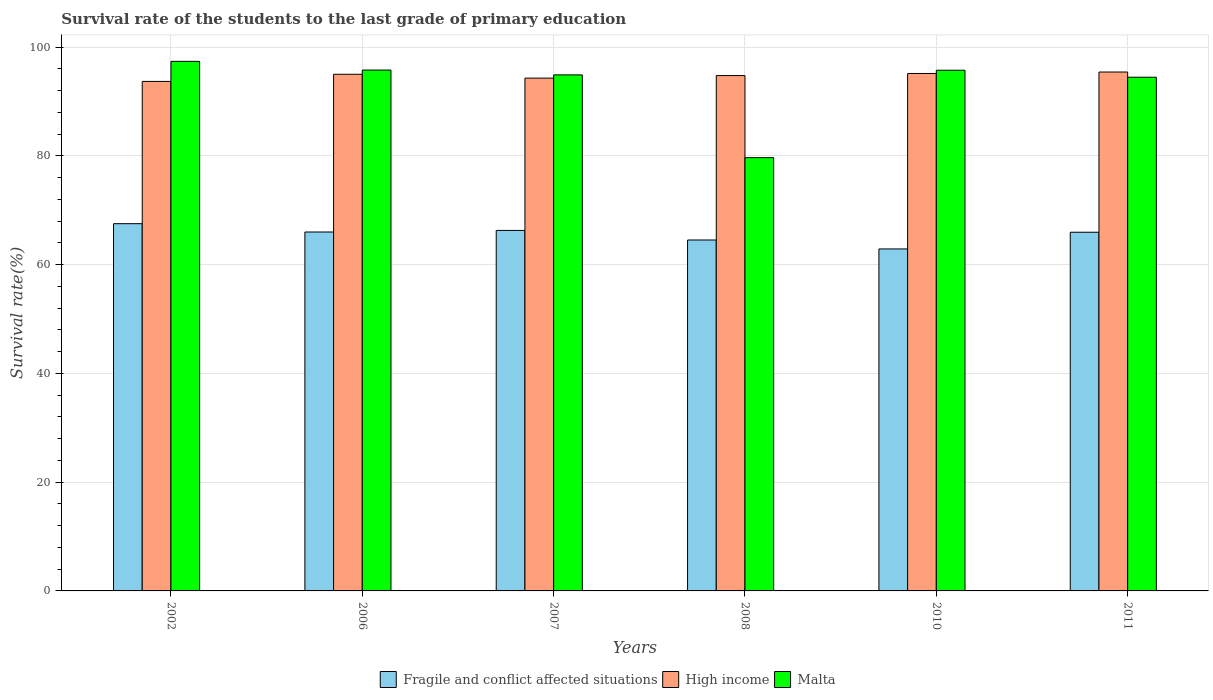How many groups of bars are there?
Offer a terse response. 6. How many bars are there on the 5th tick from the left?
Your response must be concise. 3. What is the label of the 3rd group of bars from the left?
Your answer should be very brief. 2007. What is the survival rate of the students in High income in 2010?
Provide a succinct answer. 95.15. Across all years, what is the maximum survival rate of the students in Fragile and conflict affected situations?
Keep it short and to the point. 67.53. Across all years, what is the minimum survival rate of the students in High income?
Make the answer very short. 93.69. In which year was the survival rate of the students in Fragile and conflict affected situations maximum?
Offer a very short reply. 2002. In which year was the survival rate of the students in Malta minimum?
Your answer should be compact. 2008. What is the total survival rate of the students in High income in the graph?
Offer a very short reply. 568.33. What is the difference between the survival rate of the students in High income in 2002 and that in 2006?
Keep it short and to the point. -1.31. What is the difference between the survival rate of the students in Fragile and conflict affected situations in 2008 and the survival rate of the students in High income in 2002?
Your answer should be very brief. -29.16. What is the average survival rate of the students in Fragile and conflict affected situations per year?
Ensure brevity in your answer.  65.53. In the year 2006, what is the difference between the survival rate of the students in Malta and survival rate of the students in Fragile and conflict affected situations?
Your response must be concise. 29.78. In how many years, is the survival rate of the students in Malta greater than 56 %?
Your answer should be very brief. 6. What is the ratio of the survival rate of the students in High income in 2002 to that in 2010?
Give a very brief answer. 0.98. Is the survival rate of the students in Malta in 2002 less than that in 2008?
Ensure brevity in your answer.  No. Is the difference between the survival rate of the students in Malta in 2002 and 2007 greater than the difference between the survival rate of the students in Fragile and conflict affected situations in 2002 and 2007?
Provide a short and direct response. Yes. What is the difference between the highest and the second highest survival rate of the students in High income?
Your answer should be compact. 0.27. What is the difference between the highest and the lowest survival rate of the students in High income?
Give a very brief answer. 1.73. What does the 1st bar from the left in 2008 represents?
Give a very brief answer. Fragile and conflict affected situations. What does the 2nd bar from the right in 2011 represents?
Keep it short and to the point. High income. How many bars are there?
Offer a terse response. 18. How many years are there in the graph?
Your answer should be compact. 6. Where does the legend appear in the graph?
Make the answer very short. Bottom center. How are the legend labels stacked?
Offer a terse response. Horizontal. What is the title of the graph?
Make the answer very short. Survival rate of the students to the last grade of primary education. Does "Papua New Guinea" appear as one of the legend labels in the graph?
Give a very brief answer. No. What is the label or title of the Y-axis?
Provide a succinct answer. Survival rate(%). What is the Survival rate(%) in Fragile and conflict affected situations in 2002?
Ensure brevity in your answer.  67.53. What is the Survival rate(%) in High income in 2002?
Offer a very short reply. 93.69. What is the Survival rate(%) of Malta in 2002?
Provide a short and direct response. 97.38. What is the Survival rate(%) of Fragile and conflict affected situations in 2006?
Your answer should be compact. 66. What is the Survival rate(%) in High income in 2006?
Provide a short and direct response. 95. What is the Survival rate(%) in Malta in 2006?
Provide a succinct answer. 95.78. What is the Survival rate(%) in Fragile and conflict affected situations in 2007?
Keep it short and to the point. 66.29. What is the Survival rate(%) of High income in 2007?
Keep it short and to the point. 94.3. What is the Survival rate(%) in Malta in 2007?
Give a very brief answer. 94.89. What is the Survival rate(%) in Fragile and conflict affected situations in 2008?
Your answer should be very brief. 64.53. What is the Survival rate(%) of High income in 2008?
Keep it short and to the point. 94.77. What is the Survival rate(%) in Malta in 2008?
Offer a terse response. 79.67. What is the Survival rate(%) in Fragile and conflict affected situations in 2010?
Your answer should be very brief. 62.88. What is the Survival rate(%) of High income in 2010?
Your answer should be compact. 95.15. What is the Survival rate(%) in Malta in 2010?
Give a very brief answer. 95.75. What is the Survival rate(%) in Fragile and conflict affected situations in 2011?
Make the answer very short. 65.96. What is the Survival rate(%) of High income in 2011?
Your response must be concise. 95.42. What is the Survival rate(%) in Malta in 2011?
Give a very brief answer. 94.46. Across all years, what is the maximum Survival rate(%) of Fragile and conflict affected situations?
Offer a terse response. 67.53. Across all years, what is the maximum Survival rate(%) in High income?
Your answer should be very brief. 95.42. Across all years, what is the maximum Survival rate(%) in Malta?
Give a very brief answer. 97.38. Across all years, what is the minimum Survival rate(%) in Fragile and conflict affected situations?
Offer a terse response. 62.88. Across all years, what is the minimum Survival rate(%) in High income?
Your answer should be very brief. 93.69. Across all years, what is the minimum Survival rate(%) of Malta?
Your answer should be very brief. 79.67. What is the total Survival rate(%) of Fragile and conflict affected situations in the graph?
Offer a very short reply. 393.19. What is the total Survival rate(%) in High income in the graph?
Offer a terse response. 568.33. What is the total Survival rate(%) in Malta in the graph?
Provide a succinct answer. 557.94. What is the difference between the Survival rate(%) in Fragile and conflict affected situations in 2002 and that in 2006?
Provide a succinct answer. 1.53. What is the difference between the Survival rate(%) in High income in 2002 and that in 2006?
Give a very brief answer. -1.31. What is the difference between the Survival rate(%) of Malta in 2002 and that in 2006?
Provide a succinct answer. 1.6. What is the difference between the Survival rate(%) of Fragile and conflict affected situations in 2002 and that in 2007?
Make the answer very short. 1.24. What is the difference between the Survival rate(%) of High income in 2002 and that in 2007?
Make the answer very short. -0.6. What is the difference between the Survival rate(%) in Malta in 2002 and that in 2007?
Give a very brief answer. 2.49. What is the difference between the Survival rate(%) of Fragile and conflict affected situations in 2002 and that in 2008?
Your response must be concise. 3. What is the difference between the Survival rate(%) in High income in 2002 and that in 2008?
Provide a short and direct response. -1.07. What is the difference between the Survival rate(%) in Malta in 2002 and that in 2008?
Give a very brief answer. 17.71. What is the difference between the Survival rate(%) in Fragile and conflict affected situations in 2002 and that in 2010?
Give a very brief answer. 4.65. What is the difference between the Survival rate(%) of High income in 2002 and that in 2010?
Keep it short and to the point. -1.46. What is the difference between the Survival rate(%) of Malta in 2002 and that in 2010?
Keep it short and to the point. 1.63. What is the difference between the Survival rate(%) in Fragile and conflict affected situations in 2002 and that in 2011?
Provide a short and direct response. 1.58. What is the difference between the Survival rate(%) of High income in 2002 and that in 2011?
Keep it short and to the point. -1.73. What is the difference between the Survival rate(%) of Malta in 2002 and that in 2011?
Keep it short and to the point. 2.92. What is the difference between the Survival rate(%) of Fragile and conflict affected situations in 2006 and that in 2007?
Your response must be concise. -0.29. What is the difference between the Survival rate(%) of High income in 2006 and that in 2007?
Give a very brief answer. 0.71. What is the difference between the Survival rate(%) in Malta in 2006 and that in 2007?
Your response must be concise. 0.89. What is the difference between the Survival rate(%) in Fragile and conflict affected situations in 2006 and that in 2008?
Provide a succinct answer. 1.47. What is the difference between the Survival rate(%) of High income in 2006 and that in 2008?
Your answer should be compact. 0.24. What is the difference between the Survival rate(%) in Malta in 2006 and that in 2008?
Your answer should be very brief. 16.11. What is the difference between the Survival rate(%) in Fragile and conflict affected situations in 2006 and that in 2010?
Your answer should be compact. 3.11. What is the difference between the Survival rate(%) of High income in 2006 and that in 2010?
Your answer should be compact. -0.15. What is the difference between the Survival rate(%) in Malta in 2006 and that in 2010?
Your response must be concise. 0.03. What is the difference between the Survival rate(%) in Fragile and conflict affected situations in 2006 and that in 2011?
Ensure brevity in your answer.  0.04. What is the difference between the Survival rate(%) in High income in 2006 and that in 2011?
Your answer should be very brief. -0.41. What is the difference between the Survival rate(%) of Malta in 2006 and that in 2011?
Give a very brief answer. 1.32. What is the difference between the Survival rate(%) of Fragile and conflict affected situations in 2007 and that in 2008?
Offer a very short reply. 1.76. What is the difference between the Survival rate(%) of High income in 2007 and that in 2008?
Make the answer very short. -0.47. What is the difference between the Survival rate(%) in Malta in 2007 and that in 2008?
Give a very brief answer. 15.22. What is the difference between the Survival rate(%) of Fragile and conflict affected situations in 2007 and that in 2010?
Offer a terse response. 3.4. What is the difference between the Survival rate(%) of High income in 2007 and that in 2010?
Your answer should be very brief. -0.85. What is the difference between the Survival rate(%) of Malta in 2007 and that in 2010?
Keep it short and to the point. -0.86. What is the difference between the Survival rate(%) in Fragile and conflict affected situations in 2007 and that in 2011?
Provide a short and direct response. 0.33. What is the difference between the Survival rate(%) in High income in 2007 and that in 2011?
Provide a short and direct response. -1.12. What is the difference between the Survival rate(%) in Malta in 2007 and that in 2011?
Give a very brief answer. 0.43. What is the difference between the Survival rate(%) of Fragile and conflict affected situations in 2008 and that in 2010?
Offer a terse response. 1.65. What is the difference between the Survival rate(%) of High income in 2008 and that in 2010?
Offer a very short reply. -0.39. What is the difference between the Survival rate(%) in Malta in 2008 and that in 2010?
Offer a terse response. -16.08. What is the difference between the Survival rate(%) in Fragile and conflict affected situations in 2008 and that in 2011?
Offer a very short reply. -1.43. What is the difference between the Survival rate(%) of High income in 2008 and that in 2011?
Your response must be concise. -0.65. What is the difference between the Survival rate(%) in Malta in 2008 and that in 2011?
Provide a succinct answer. -14.79. What is the difference between the Survival rate(%) in Fragile and conflict affected situations in 2010 and that in 2011?
Provide a succinct answer. -3.07. What is the difference between the Survival rate(%) in High income in 2010 and that in 2011?
Give a very brief answer. -0.27. What is the difference between the Survival rate(%) in Malta in 2010 and that in 2011?
Your answer should be very brief. 1.29. What is the difference between the Survival rate(%) in Fragile and conflict affected situations in 2002 and the Survival rate(%) in High income in 2006?
Offer a terse response. -27.47. What is the difference between the Survival rate(%) in Fragile and conflict affected situations in 2002 and the Survival rate(%) in Malta in 2006?
Offer a very short reply. -28.25. What is the difference between the Survival rate(%) of High income in 2002 and the Survival rate(%) of Malta in 2006?
Give a very brief answer. -2.09. What is the difference between the Survival rate(%) in Fragile and conflict affected situations in 2002 and the Survival rate(%) in High income in 2007?
Provide a short and direct response. -26.77. What is the difference between the Survival rate(%) of Fragile and conflict affected situations in 2002 and the Survival rate(%) of Malta in 2007?
Provide a succinct answer. -27.36. What is the difference between the Survival rate(%) of High income in 2002 and the Survival rate(%) of Malta in 2007?
Offer a terse response. -1.2. What is the difference between the Survival rate(%) of Fragile and conflict affected situations in 2002 and the Survival rate(%) of High income in 2008?
Your answer should be very brief. -27.23. What is the difference between the Survival rate(%) of Fragile and conflict affected situations in 2002 and the Survival rate(%) of Malta in 2008?
Keep it short and to the point. -12.14. What is the difference between the Survival rate(%) of High income in 2002 and the Survival rate(%) of Malta in 2008?
Offer a very short reply. 14.02. What is the difference between the Survival rate(%) of Fragile and conflict affected situations in 2002 and the Survival rate(%) of High income in 2010?
Offer a very short reply. -27.62. What is the difference between the Survival rate(%) in Fragile and conflict affected situations in 2002 and the Survival rate(%) in Malta in 2010?
Make the answer very short. -28.22. What is the difference between the Survival rate(%) of High income in 2002 and the Survival rate(%) of Malta in 2010?
Provide a succinct answer. -2.06. What is the difference between the Survival rate(%) in Fragile and conflict affected situations in 2002 and the Survival rate(%) in High income in 2011?
Offer a very short reply. -27.89. What is the difference between the Survival rate(%) in Fragile and conflict affected situations in 2002 and the Survival rate(%) in Malta in 2011?
Offer a terse response. -26.93. What is the difference between the Survival rate(%) of High income in 2002 and the Survival rate(%) of Malta in 2011?
Make the answer very short. -0.77. What is the difference between the Survival rate(%) in Fragile and conflict affected situations in 2006 and the Survival rate(%) in High income in 2007?
Offer a very short reply. -28.3. What is the difference between the Survival rate(%) in Fragile and conflict affected situations in 2006 and the Survival rate(%) in Malta in 2007?
Ensure brevity in your answer.  -28.89. What is the difference between the Survival rate(%) in High income in 2006 and the Survival rate(%) in Malta in 2007?
Offer a very short reply. 0.11. What is the difference between the Survival rate(%) of Fragile and conflict affected situations in 2006 and the Survival rate(%) of High income in 2008?
Give a very brief answer. -28.77. What is the difference between the Survival rate(%) in Fragile and conflict affected situations in 2006 and the Survival rate(%) in Malta in 2008?
Make the answer very short. -13.67. What is the difference between the Survival rate(%) of High income in 2006 and the Survival rate(%) of Malta in 2008?
Offer a terse response. 15.33. What is the difference between the Survival rate(%) in Fragile and conflict affected situations in 2006 and the Survival rate(%) in High income in 2010?
Give a very brief answer. -29.15. What is the difference between the Survival rate(%) in Fragile and conflict affected situations in 2006 and the Survival rate(%) in Malta in 2010?
Ensure brevity in your answer.  -29.75. What is the difference between the Survival rate(%) in High income in 2006 and the Survival rate(%) in Malta in 2010?
Your response must be concise. -0.75. What is the difference between the Survival rate(%) of Fragile and conflict affected situations in 2006 and the Survival rate(%) of High income in 2011?
Keep it short and to the point. -29.42. What is the difference between the Survival rate(%) of Fragile and conflict affected situations in 2006 and the Survival rate(%) of Malta in 2011?
Your answer should be very brief. -28.46. What is the difference between the Survival rate(%) of High income in 2006 and the Survival rate(%) of Malta in 2011?
Provide a short and direct response. 0.54. What is the difference between the Survival rate(%) in Fragile and conflict affected situations in 2007 and the Survival rate(%) in High income in 2008?
Offer a terse response. -28.48. What is the difference between the Survival rate(%) of Fragile and conflict affected situations in 2007 and the Survival rate(%) of Malta in 2008?
Provide a short and direct response. -13.38. What is the difference between the Survival rate(%) in High income in 2007 and the Survival rate(%) in Malta in 2008?
Provide a succinct answer. 14.62. What is the difference between the Survival rate(%) in Fragile and conflict affected situations in 2007 and the Survival rate(%) in High income in 2010?
Offer a very short reply. -28.86. What is the difference between the Survival rate(%) in Fragile and conflict affected situations in 2007 and the Survival rate(%) in Malta in 2010?
Provide a short and direct response. -29.46. What is the difference between the Survival rate(%) of High income in 2007 and the Survival rate(%) of Malta in 2010?
Offer a terse response. -1.45. What is the difference between the Survival rate(%) in Fragile and conflict affected situations in 2007 and the Survival rate(%) in High income in 2011?
Provide a succinct answer. -29.13. What is the difference between the Survival rate(%) in Fragile and conflict affected situations in 2007 and the Survival rate(%) in Malta in 2011?
Your answer should be compact. -28.17. What is the difference between the Survival rate(%) in High income in 2007 and the Survival rate(%) in Malta in 2011?
Your response must be concise. -0.17. What is the difference between the Survival rate(%) in Fragile and conflict affected situations in 2008 and the Survival rate(%) in High income in 2010?
Provide a short and direct response. -30.62. What is the difference between the Survival rate(%) in Fragile and conflict affected situations in 2008 and the Survival rate(%) in Malta in 2010?
Your answer should be very brief. -31.22. What is the difference between the Survival rate(%) in High income in 2008 and the Survival rate(%) in Malta in 2010?
Your response must be concise. -0.98. What is the difference between the Survival rate(%) of Fragile and conflict affected situations in 2008 and the Survival rate(%) of High income in 2011?
Provide a short and direct response. -30.89. What is the difference between the Survival rate(%) of Fragile and conflict affected situations in 2008 and the Survival rate(%) of Malta in 2011?
Give a very brief answer. -29.93. What is the difference between the Survival rate(%) in High income in 2008 and the Survival rate(%) in Malta in 2011?
Your answer should be compact. 0.3. What is the difference between the Survival rate(%) of Fragile and conflict affected situations in 2010 and the Survival rate(%) of High income in 2011?
Offer a very short reply. -32.53. What is the difference between the Survival rate(%) in Fragile and conflict affected situations in 2010 and the Survival rate(%) in Malta in 2011?
Provide a succinct answer. -31.58. What is the difference between the Survival rate(%) in High income in 2010 and the Survival rate(%) in Malta in 2011?
Make the answer very short. 0.69. What is the average Survival rate(%) in Fragile and conflict affected situations per year?
Provide a short and direct response. 65.53. What is the average Survival rate(%) in High income per year?
Your answer should be compact. 94.72. What is the average Survival rate(%) of Malta per year?
Offer a very short reply. 92.99. In the year 2002, what is the difference between the Survival rate(%) of Fragile and conflict affected situations and Survival rate(%) of High income?
Ensure brevity in your answer.  -26.16. In the year 2002, what is the difference between the Survival rate(%) in Fragile and conflict affected situations and Survival rate(%) in Malta?
Ensure brevity in your answer.  -29.85. In the year 2002, what is the difference between the Survival rate(%) in High income and Survival rate(%) in Malta?
Keep it short and to the point. -3.69. In the year 2006, what is the difference between the Survival rate(%) in Fragile and conflict affected situations and Survival rate(%) in High income?
Your answer should be very brief. -29. In the year 2006, what is the difference between the Survival rate(%) of Fragile and conflict affected situations and Survival rate(%) of Malta?
Offer a very short reply. -29.78. In the year 2006, what is the difference between the Survival rate(%) in High income and Survival rate(%) in Malta?
Ensure brevity in your answer.  -0.78. In the year 2007, what is the difference between the Survival rate(%) of Fragile and conflict affected situations and Survival rate(%) of High income?
Make the answer very short. -28.01. In the year 2007, what is the difference between the Survival rate(%) of Fragile and conflict affected situations and Survival rate(%) of Malta?
Ensure brevity in your answer.  -28.6. In the year 2007, what is the difference between the Survival rate(%) of High income and Survival rate(%) of Malta?
Your answer should be very brief. -0.59. In the year 2008, what is the difference between the Survival rate(%) in Fragile and conflict affected situations and Survival rate(%) in High income?
Offer a very short reply. -30.24. In the year 2008, what is the difference between the Survival rate(%) of Fragile and conflict affected situations and Survival rate(%) of Malta?
Ensure brevity in your answer.  -15.14. In the year 2008, what is the difference between the Survival rate(%) of High income and Survival rate(%) of Malta?
Provide a succinct answer. 15.09. In the year 2010, what is the difference between the Survival rate(%) of Fragile and conflict affected situations and Survival rate(%) of High income?
Your answer should be compact. -32.27. In the year 2010, what is the difference between the Survival rate(%) of Fragile and conflict affected situations and Survival rate(%) of Malta?
Ensure brevity in your answer.  -32.86. In the year 2010, what is the difference between the Survival rate(%) in High income and Survival rate(%) in Malta?
Offer a terse response. -0.6. In the year 2011, what is the difference between the Survival rate(%) in Fragile and conflict affected situations and Survival rate(%) in High income?
Provide a succinct answer. -29.46. In the year 2011, what is the difference between the Survival rate(%) of Fragile and conflict affected situations and Survival rate(%) of Malta?
Provide a short and direct response. -28.51. In the year 2011, what is the difference between the Survival rate(%) of High income and Survival rate(%) of Malta?
Your answer should be very brief. 0.95. What is the ratio of the Survival rate(%) in Fragile and conflict affected situations in 2002 to that in 2006?
Offer a very short reply. 1.02. What is the ratio of the Survival rate(%) in High income in 2002 to that in 2006?
Ensure brevity in your answer.  0.99. What is the ratio of the Survival rate(%) of Malta in 2002 to that in 2006?
Make the answer very short. 1.02. What is the ratio of the Survival rate(%) in Fragile and conflict affected situations in 2002 to that in 2007?
Provide a succinct answer. 1.02. What is the ratio of the Survival rate(%) of High income in 2002 to that in 2007?
Your answer should be compact. 0.99. What is the ratio of the Survival rate(%) of Malta in 2002 to that in 2007?
Provide a short and direct response. 1.03. What is the ratio of the Survival rate(%) in Fragile and conflict affected situations in 2002 to that in 2008?
Your answer should be very brief. 1.05. What is the ratio of the Survival rate(%) of High income in 2002 to that in 2008?
Ensure brevity in your answer.  0.99. What is the ratio of the Survival rate(%) of Malta in 2002 to that in 2008?
Make the answer very short. 1.22. What is the ratio of the Survival rate(%) in Fragile and conflict affected situations in 2002 to that in 2010?
Provide a short and direct response. 1.07. What is the ratio of the Survival rate(%) in High income in 2002 to that in 2010?
Keep it short and to the point. 0.98. What is the ratio of the Survival rate(%) of Fragile and conflict affected situations in 2002 to that in 2011?
Offer a very short reply. 1.02. What is the ratio of the Survival rate(%) in High income in 2002 to that in 2011?
Your answer should be very brief. 0.98. What is the ratio of the Survival rate(%) of Malta in 2002 to that in 2011?
Provide a short and direct response. 1.03. What is the ratio of the Survival rate(%) in Fragile and conflict affected situations in 2006 to that in 2007?
Ensure brevity in your answer.  1. What is the ratio of the Survival rate(%) in High income in 2006 to that in 2007?
Make the answer very short. 1.01. What is the ratio of the Survival rate(%) in Malta in 2006 to that in 2007?
Provide a short and direct response. 1.01. What is the ratio of the Survival rate(%) in Fragile and conflict affected situations in 2006 to that in 2008?
Give a very brief answer. 1.02. What is the ratio of the Survival rate(%) of High income in 2006 to that in 2008?
Make the answer very short. 1. What is the ratio of the Survival rate(%) in Malta in 2006 to that in 2008?
Your response must be concise. 1.2. What is the ratio of the Survival rate(%) in Fragile and conflict affected situations in 2006 to that in 2010?
Make the answer very short. 1.05. What is the ratio of the Survival rate(%) of High income in 2006 to that in 2010?
Your answer should be very brief. 1. What is the ratio of the Survival rate(%) of Malta in 2006 to that in 2011?
Ensure brevity in your answer.  1.01. What is the ratio of the Survival rate(%) in Fragile and conflict affected situations in 2007 to that in 2008?
Provide a short and direct response. 1.03. What is the ratio of the Survival rate(%) of High income in 2007 to that in 2008?
Provide a succinct answer. 1. What is the ratio of the Survival rate(%) in Malta in 2007 to that in 2008?
Your answer should be very brief. 1.19. What is the ratio of the Survival rate(%) of Fragile and conflict affected situations in 2007 to that in 2010?
Your answer should be very brief. 1.05. What is the ratio of the Survival rate(%) in High income in 2007 to that in 2011?
Make the answer very short. 0.99. What is the ratio of the Survival rate(%) in Fragile and conflict affected situations in 2008 to that in 2010?
Offer a terse response. 1.03. What is the ratio of the Survival rate(%) of Malta in 2008 to that in 2010?
Your answer should be very brief. 0.83. What is the ratio of the Survival rate(%) of Fragile and conflict affected situations in 2008 to that in 2011?
Keep it short and to the point. 0.98. What is the ratio of the Survival rate(%) of High income in 2008 to that in 2011?
Give a very brief answer. 0.99. What is the ratio of the Survival rate(%) of Malta in 2008 to that in 2011?
Provide a succinct answer. 0.84. What is the ratio of the Survival rate(%) of Fragile and conflict affected situations in 2010 to that in 2011?
Your answer should be very brief. 0.95. What is the ratio of the Survival rate(%) in Malta in 2010 to that in 2011?
Offer a very short reply. 1.01. What is the difference between the highest and the second highest Survival rate(%) in Fragile and conflict affected situations?
Ensure brevity in your answer.  1.24. What is the difference between the highest and the second highest Survival rate(%) in High income?
Keep it short and to the point. 0.27. What is the difference between the highest and the second highest Survival rate(%) in Malta?
Keep it short and to the point. 1.6. What is the difference between the highest and the lowest Survival rate(%) in Fragile and conflict affected situations?
Your answer should be compact. 4.65. What is the difference between the highest and the lowest Survival rate(%) of High income?
Provide a short and direct response. 1.73. What is the difference between the highest and the lowest Survival rate(%) in Malta?
Keep it short and to the point. 17.71. 